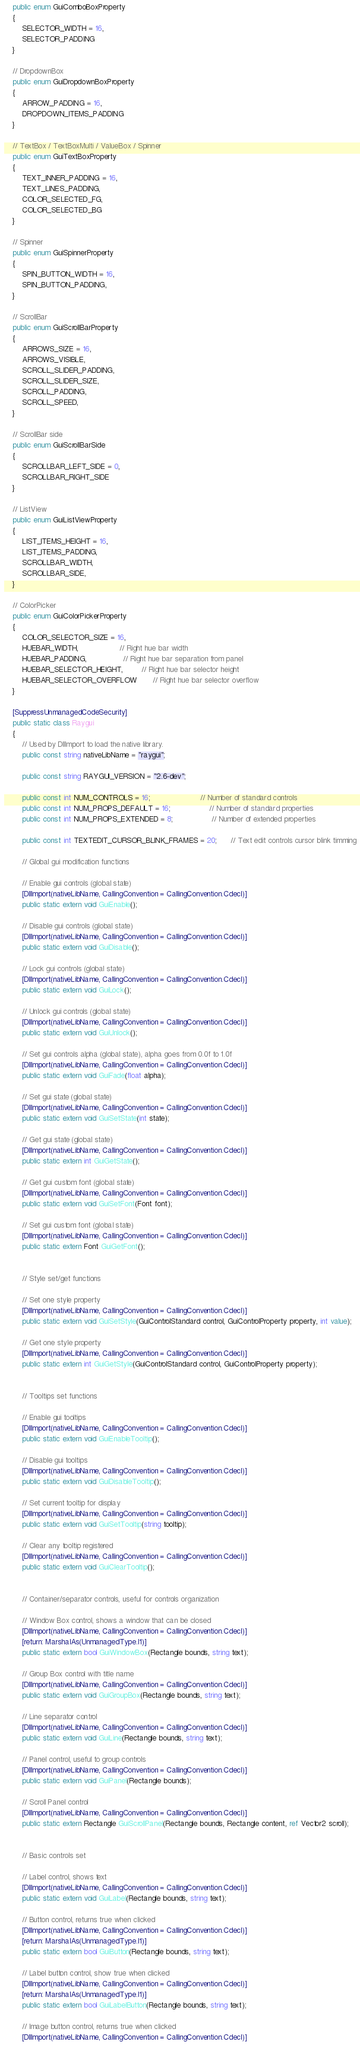Convert code to text. <code><loc_0><loc_0><loc_500><loc_500><_C#_>    public enum GuiComboBoxProperty
    {
        SELECTOR_WIDTH = 16,
        SELECTOR_PADDING
    }

    // DropdownBox
    public enum GuiDropdownBoxProperty
    {
        ARROW_PADDING = 16,
        DROPDOWN_ITEMS_PADDING
    }

    // TextBox / TextBoxMulti / ValueBox / Spinner
    public enum GuiTextBoxProperty
    {
        TEXT_INNER_PADDING = 16,
        TEXT_LINES_PADDING,
        COLOR_SELECTED_FG,
        COLOR_SELECTED_BG
    }

    // Spinner
    public enum GuiSpinnerProperty
    {
        SPIN_BUTTON_WIDTH = 16,
        SPIN_BUTTON_PADDING,
    }

    // ScrollBar
    public enum GuiScrollBarProperty
    {
        ARROWS_SIZE = 16,
        ARROWS_VISIBLE,
        SCROLL_SLIDER_PADDING,
        SCROLL_SLIDER_SIZE,
        SCROLL_PADDING,
        SCROLL_SPEED,
    }

    // ScrollBar side
    public enum GuiScrollBarSide
    {
        SCROLLBAR_LEFT_SIDE = 0,
        SCROLLBAR_RIGHT_SIDE
    }

    // ListView
    public enum GuiListViewProperty
    {
        LIST_ITEMS_HEIGHT = 16,
        LIST_ITEMS_PADDING,
        SCROLLBAR_WIDTH,
        SCROLLBAR_SIDE,
    }

    // ColorPicker
    public enum GuiColorPickerProperty
    {
        COLOR_SELECTOR_SIZE = 16,
        HUEBAR_WIDTH,                  // Right hue bar width
        HUEBAR_PADDING,                // Right hue bar separation from panel
        HUEBAR_SELECTOR_HEIGHT,        // Right hue bar selector height
        HUEBAR_SELECTOR_OVERFLOW       // Right hue bar selector overflow
    }

    [SuppressUnmanagedCodeSecurity]
    public static class Raygui
    {
        // Used by DllImport to load the native library.
        public const string nativeLibName = "raygui";

        public const string RAYGUI_VERSION = "2.6-dev";

        public const int NUM_CONTROLS = 16;                      // Number of standard controls
        public const int NUM_PROPS_DEFAULT = 16;                 // Number of standard properties
        public const int NUM_PROPS_EXTENDED = 8;                 // Number of extended properties

        public const int TEXTEDIT_CURSOR_BLINK_FRAMES = 20;      // Text edit controls cursor blink timming

        // Global gui modification functions

        // Enable gui controls (global state)
        [DllImport(nativeLibName, CallingConvention = CallingConvention.Cdecl)]
        public static extern void GuiEnable();

        // Disable gui controls (global state)
        [DllImport(nativeLibName, CallingConvention = CallingConvention.Cdecl)]
        public static extern void GuiDisable();

        // Lock gui controls (global state)
        [DllImport(nativeLibName, CallingConvention = CallingConvention.Cdecl)]
        public static extern void GuiLock();

        // Unlock gui controls (global state)
        [DllImport(nativeLibName, CallingConvention = CallingConvention.Cdecl)]
        public static extern void GuiUnlock();

        // Set gui controls alpha (global state), alpha goes from 0.0f to 1.0f
        [DllImport(nativeLibName, CallingConvention = CallingConvention.Cdecl)]
        public static extern void GuiFade(float alpha);

        // Set gui state (global state)
        [DllImport(nativeLibName, CallingConvention = CallingConvention.Cdecl)]
        public static extern void GuiSetState(int state);

        // Get gui state (global state)
        [DllImport(nativeLibName, CallingConvention = CallingConvention.Cdecl)]
        public static extern int GuiGetState();

        // Get gui custom font (global state)
        [DllImport(nativeLibName, CallingConvention = CallingConvention.Cdecl)]
        public static extern void GuiSetFont(Font font);

        // Set gui custom font (global state)
        [DllImport(nativeLibName, CallingConvention = CallingConvention.Cdecl)]
        public static extern Font GuiGetFont();


        // Style set/get functions

        // Set one style property
        [DllImport(nativeLibName, CallingConvention = CallingConvention.Cdecl)]
        public static extern void GuiSetStyle(GuiControlStandard control, GuiControlProperty property, int value);

        // Get one style property
        [DllImport(nativeLibName, CallingConvention = CallingConvention.Cdecl)]
        public static extern int GuiGetStyle(GuiControlStandard control, GuiControlProperty property);


        // Tooltips set functions

        // Enable gui tooltips
        [DllImport(nativeLibName, CallingConvention = CallingConvention.Cdecl)]
        public static extern void GuiEnableTooltip();

        // Disable gui tooltips
        [DllImport(nativeLibName, CallingConvention = CallingConvention.Cdecl)]
        public static extern void GuiDisableTooltip();

        // Set current tooltip for display
        [DllImport(nativeLibName, CallingConvention = CallingConvention.Cdecl)]
        public static extern void GuiSetTooltip(string tooltip);

        // Clear any tooltip registered
        [DllImport(nativeLibName, CallingConvention = CallingConvention.Cdecl)]
        public static extern void GuiClearTooltip();


        // Container/separator controls, useful for controls organization

        // Window Box control, shows a window that can be closed
        [DllImport(nativeLibName, CallingConvention = CallingConvention.Cdecl)]
        [return: MarshalAs(UnmanagedType.I1)]
        public static extern bool GuiWindowBox(Rectangle bounds, string text);

        // Group Box control with title name
        [DllImport(nativeLibName, CallingConvention = CallingConvention.Cdecl)]
        public static extern void GuiGroupBox(Rectangle bounds, string text);

        // Line separator control
        [DllImport(nativeLibName, CallingConvention = CallingConvention.Cdecl)]
        public static extern void GuiLine(Rectangle bounds, string text);

        // Panel control, useful to group controls
        [DllImport(nativeLibName, CallingConvention = CallingConvention.Cdecl)]
        public static extern void GuiPanel(Rectangle bounds);

        // Scroll Panel control
        [DllImport(nativeLibName, CallingConvention = CallingConvention.Cdecl)]
        public static extern Rectangle GuiScrollPanel(Rectangle bounds, Rectangle content, ref Vector2 scroll);


        // Basic controls set

        // Label control, shows text
        [DllImport(nativeLibName, CallingConvention = CallingConvention.Cdecl)]
        public static extern void GuiLabel(Rectangle bounds, string text);

        // Button control, returns true when clicked
        [DllImport(nativeLibName, CallingConvention = CallingConvention.Cdecl)]
        [return: MarshalAs(UnmanagedType.I1)]
        public static extern bool GuiButton(Rectangle bounds, string text);

        // Label button control, show true when clicked
        [DllImport(nativeLibName, CallingConvention = CallingConvention.Cdecl)]
        [return: MarshalAs(UnmanagedType.I1)]
        public static extern bool GuiLabelButton(Rectangle bounds, string text);

        // Image button control, returns true when clicked
        [DllImport(nativeLibName, CallingConvention = CallingConvention.Cdecl)]</code> 